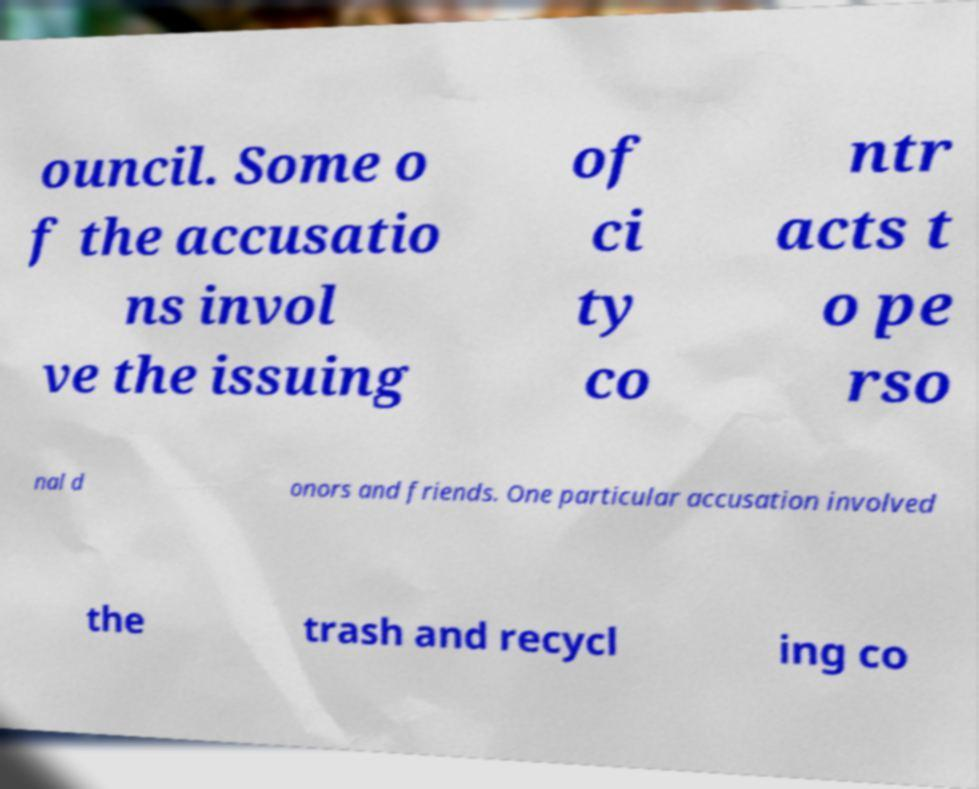Please read and relay the text visible in this image. What does it say? ouncil. Some o f the accusatio ns invol ve the issuing of ci ty co ntr acts t o pe rso nal d onors and friends. One particular accusation involved the trash and recycl ing co 